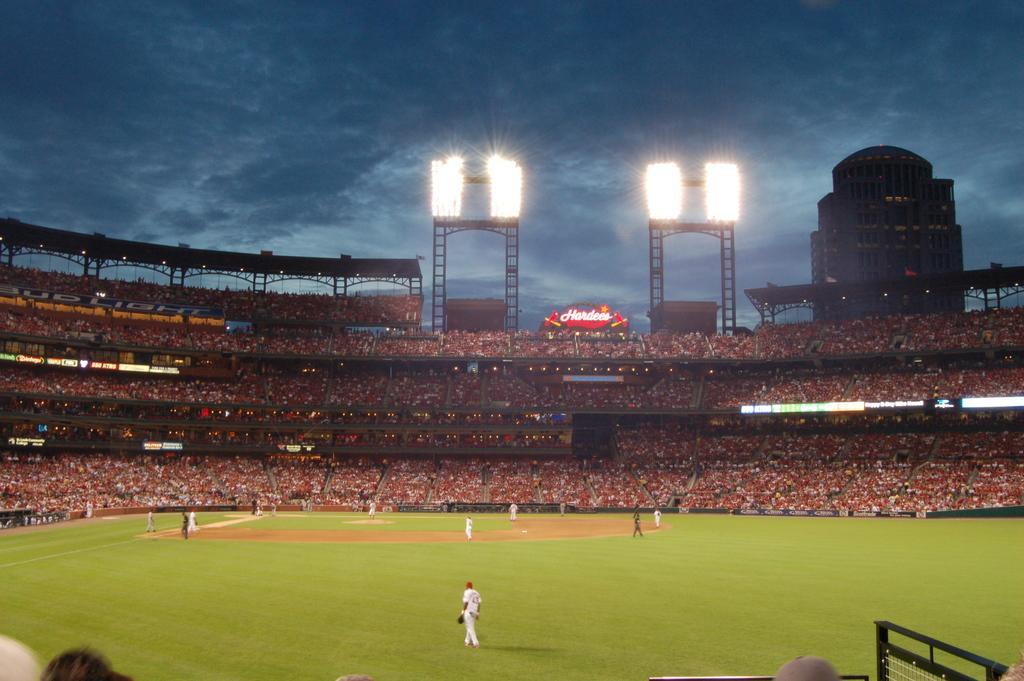Please provide a concise description of this image. In this image we can see group of people wearing dress are standing on the ground. In the background ,we can see audience ,light poles,building and the sky. 